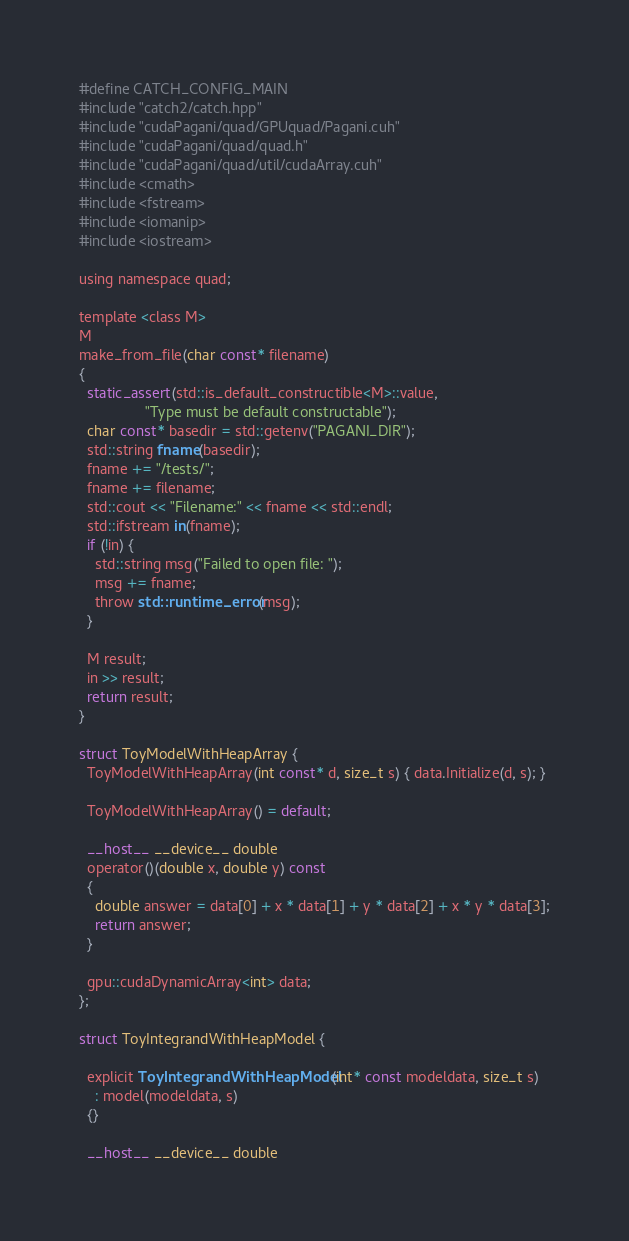<code> <loc_0><loc_0><loc_500><loc_500><_Cuda_>#define CATCH_CONFIG_MAIN
#include "catch2/catch.hpp"
#include "cudaPagani/quad/GPUquad/Pagani.cuh"
#include "cudaPagani/quad/quad.h"
#include "cudaPagani/quad/util/cudaArray.cuh"
#include <cmath>
#include <fstream>
#include <iomanip>
#include <iostream>

using namespace quad;

template <class M>
M
make_from_file(char const* filename)
{
  static_assert(std::is_default_constructible<M>::value,
                "Type must be default constructable");
  char const* basedir = std::getenv("PAGANI_DIR");
  std::string fname(basedir);
  fname += "/tests/";
  fname += filename;
  std::cout << "Filename:" << fname << std::endl;
  std::ifstream in(fname);
  if (!in) {
    std::string msg("Failed to open file: ");
    msg += fname;
    throw std::runtime_error(msg);
  }

  M result;
  in >> result;
  return result;
}

struct ToyModelWithHeapArray {
  ToyModelWithHeapArray(int const* d, size_t s) { data.Initialize(d, s); }

  ToyModelWithHeapArray() = default;

  __host__ __device__ double
  operator()(double x, double y) const
  {
    double answer = data[0] + x * data[1] + y * data[2] + x * y * data[3];
    return answer;
  }

  gpu::cudaDynamicArray<int> data;
};

struct ToyIntegrandWithHeapModel {

  explicit ToyIntegrandWithHeapModel(int* const modeldata, size_t s)
    : model(modeldata, s)
  {}

  __host__ __device__ double</code> 